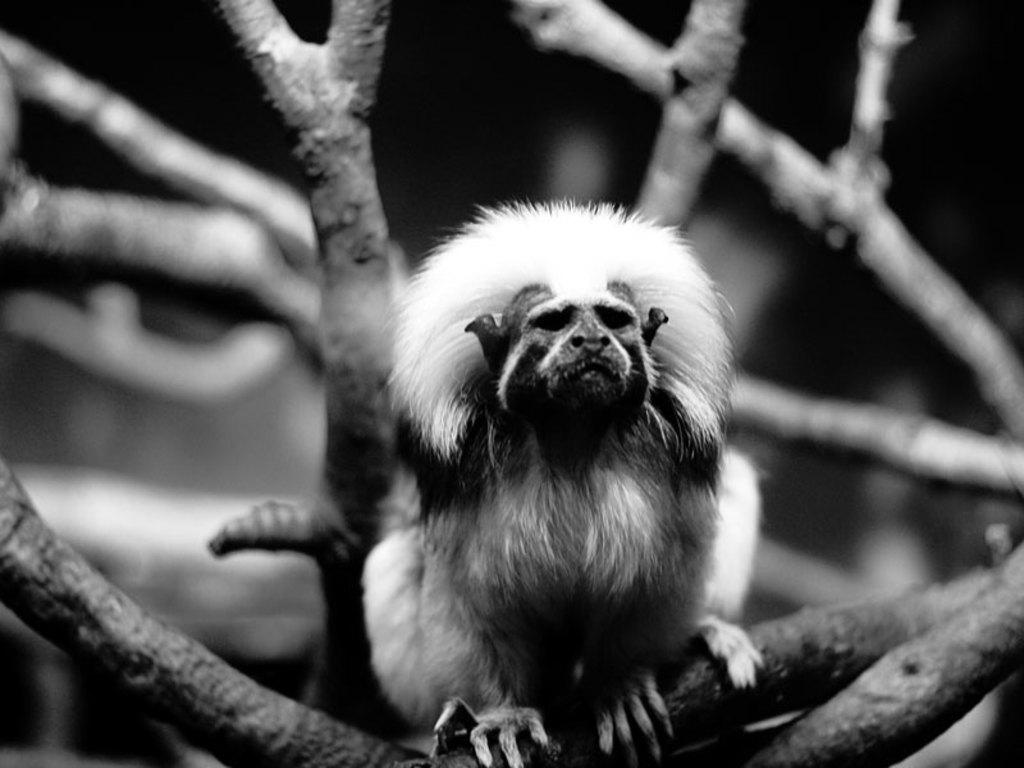What can be seen in the image? There are branches in the image. Is there anything else on the branches? Yes, there is a monkey on one of the branches. What is the color scheme of the image? The image is black and white in color. What type of oranges can be seen hanging from the branches in the image? There are no oranges present in the image; it features branches with a monkey on one of them. What drink is the monkey holding in the image? The monkey is not holding any drink in the image. 